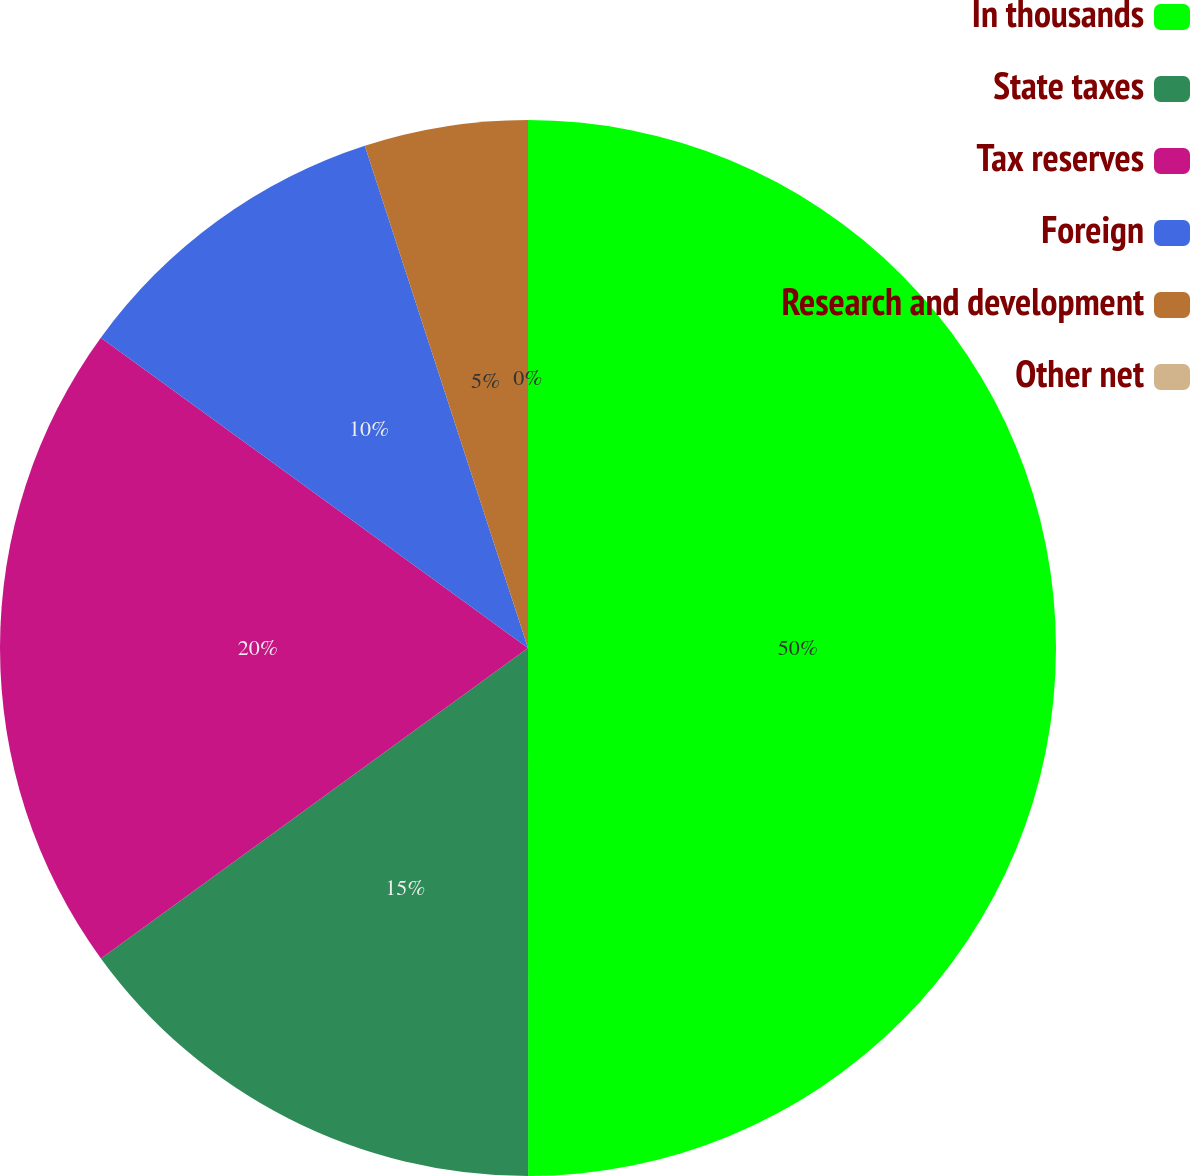<chart> <loc_0><loc_0><loc_500><loc_500><pie_chart><fcel>In thousands<fcel>State taxes<fcel>Tax reserves<fcel>Foreign<fcel>Research and development<fcel>Other net<nl><fcel>49.99%<fcel>15.0%<fcel>20.0%<fcel>10.0%<fcel>5.0%<fcel>0.0%<nl></chart> 